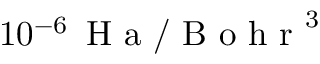Convert formula to latex. <formula><loc_0><loc_0><loc_500><loc_500>1 0 ^ { - 6 } \, H a / B o h r ^ { 3 }</formula> 